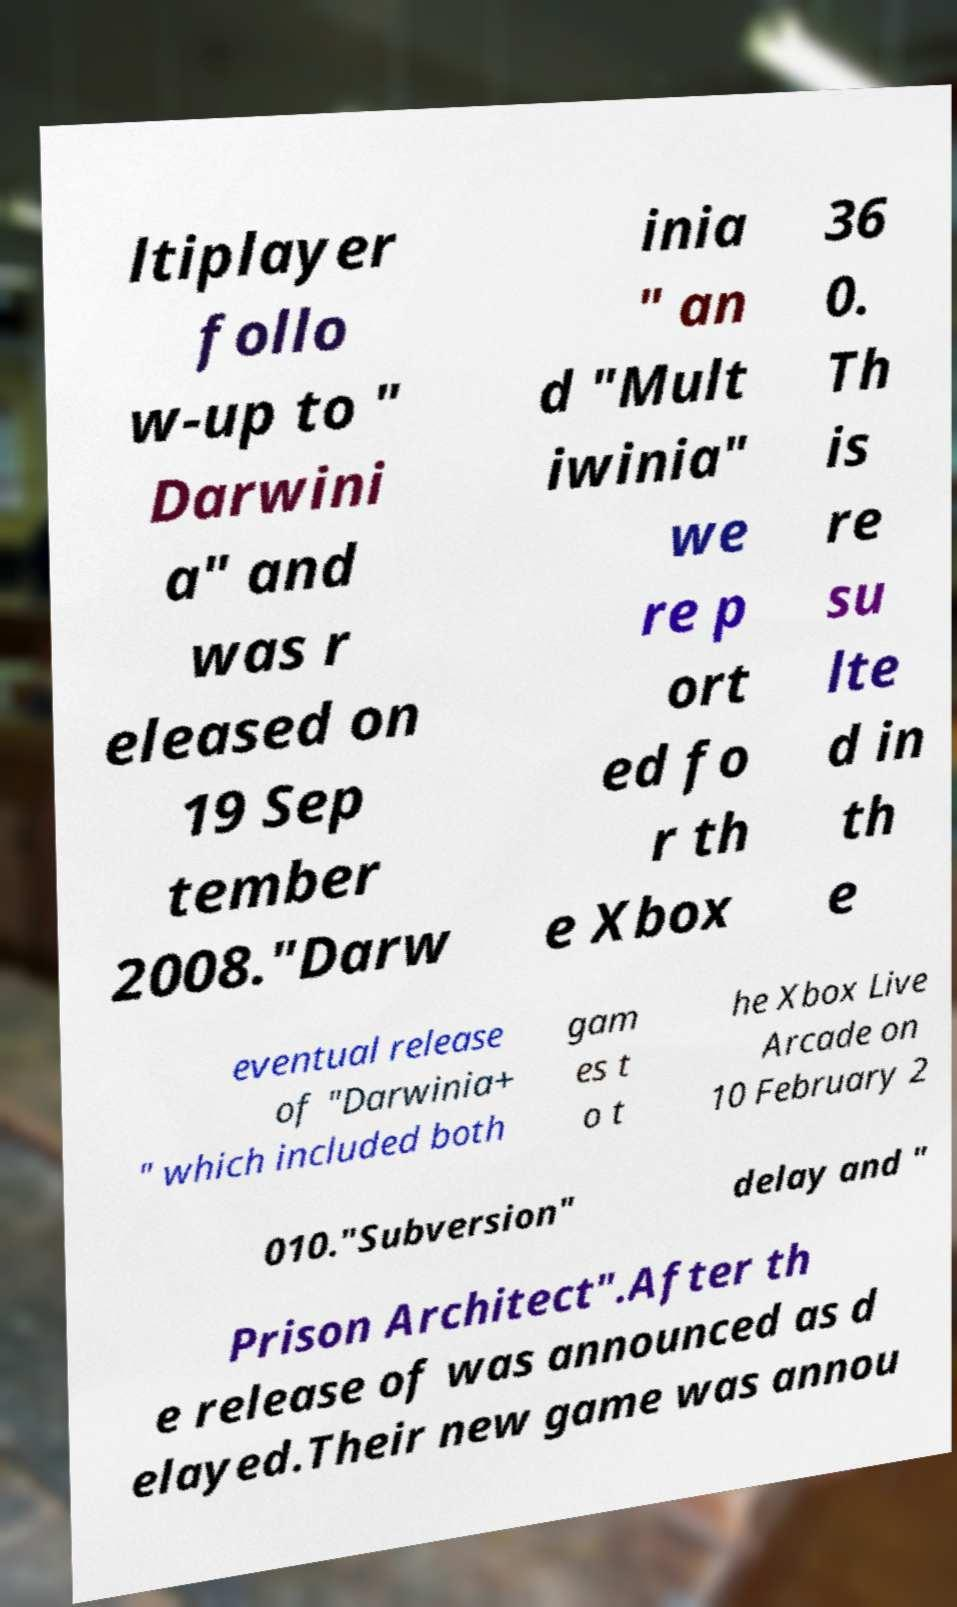Please read and relay the text visible in this image. What does it say? ltiplayer follo w-up to " Darwini a" and was r eleased on 19 Sep tember 2008."Darw inia " an d "Mult iwinia" we re p ort ed fo r th e Xbox 36 0. Th is re su lte d in th e eventual release of "Darwinia+ " which included both gam es t o t he Xbox Live Arcade on 10 February 2 010."Subversion" delay and " Prison Architect".After th e release of was announced as d elayed.Their new game was annou 